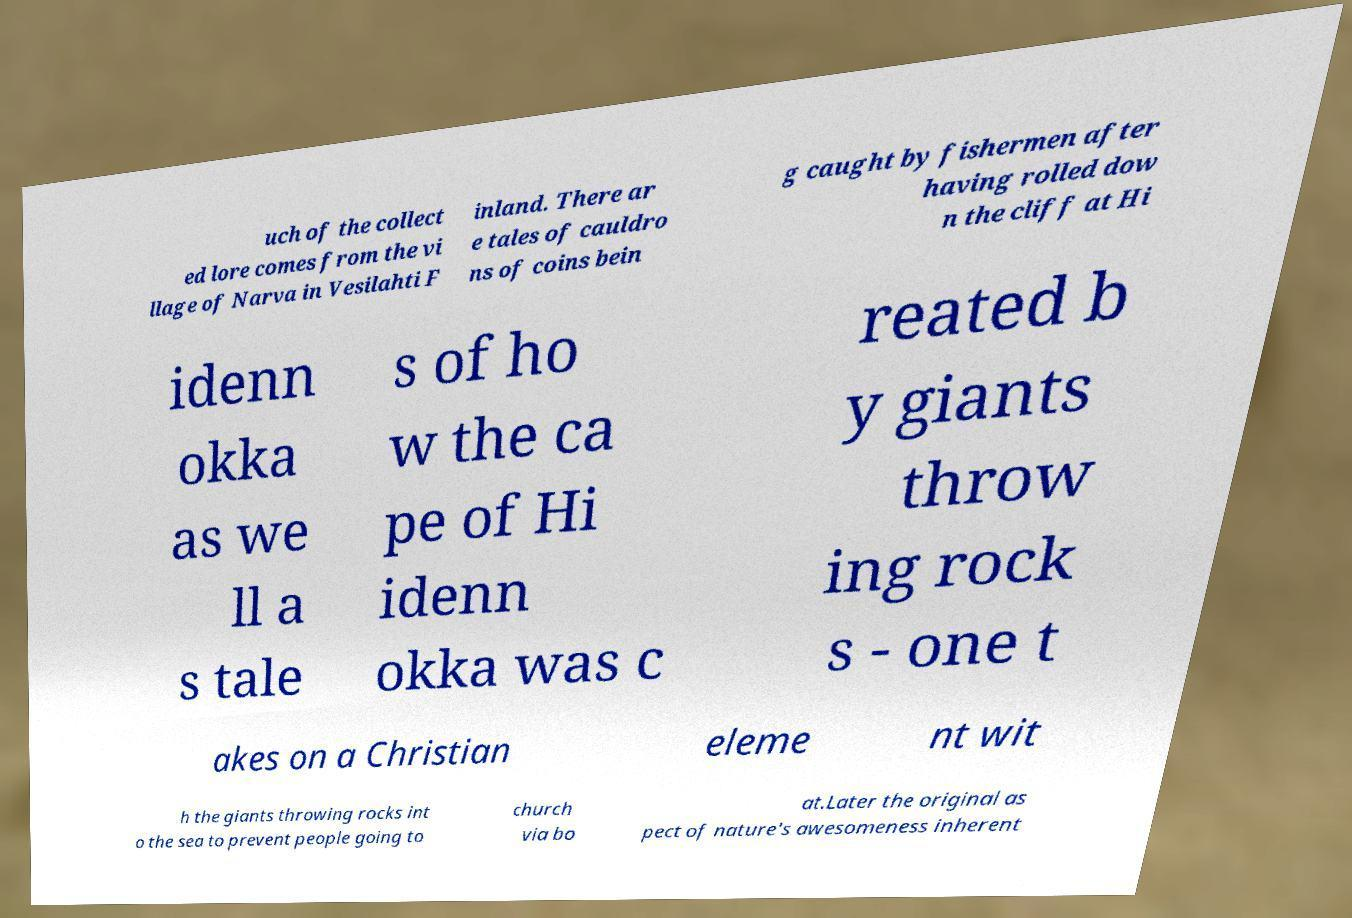There's text embedded in this image that I need extracted. Can you transcribe it verbatim? uch of the collect ed lore comes from the vi llage of Narva in Vesilahti F inland. There ar e tales of cauldro ns of coins bein g caught by fishermen after having rolled dow n the cliff at Hi idenn okka as we ll a s tale s of ho w the ca pe of Hi idenn okka was c reated b y giants throw ing rock s - one t akes on a Christian eleme nt wit h the giants throwing rocks int o the sea to prevent people going to church via bo at.Later the original as pect of nature's awesomeness inherent 